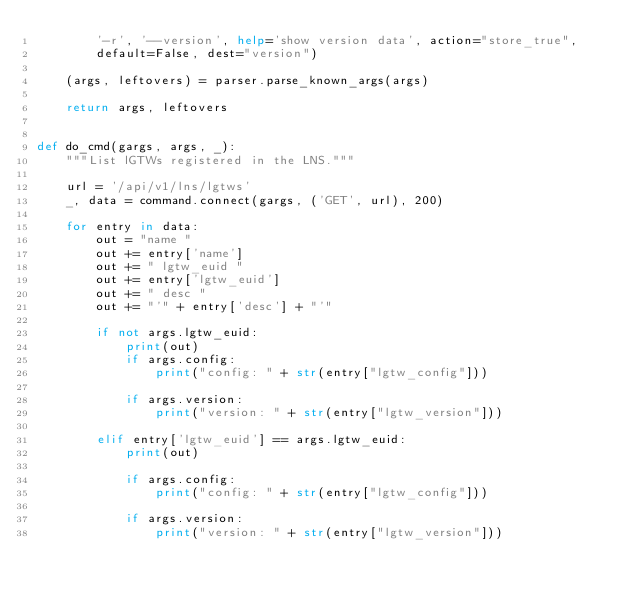<code> <loc_0><loc_0><loc_500><loc_500><_Python_>        '-r', '--version', help='show version data', action="store_true",
        default=False, dest="version")

    (args, leftovers) = parser.parse_known_args(args)

    return args, leftovers


def do_cmd(gargs, args, _):
    """List lGTWs registered in the LNS."""

    url = '/api/v1/lns/lgtws'
    _, data = command.connect(gargs, ('GET', url), 200)

    for entry in data:
        out = "name "
        out += entry['name']
        out += " lgtw_euid "
        out += entry['lgtw_euid']
        out += " desc "
        out += "'" + entry['desc'] + "'"

        if not args.lgtw_euid:
            print(out)
            if args.config:
                print("config: " + str(entry["lgtw_config"]))

            if args.version:
                print("version: " + str(entry["lgtw_version"]))

        elif entry['lgtw_euid'] == args.lgtw_euid:
            print(out)

            if args.config:
                print("config: " + str(entry["lgtw_config"]))

            if args.version:
                print("version: " + str(entry["lgtw_version"]))
</code> 